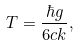<formula> <loc_0><loc_0><loc_500><loc_500>T = \frac { \hbar { g } } { 6 c k } ,</formula> 